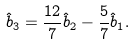Convert formula to latex. <formula><loc_0><loc_0><loc_500><loc_500>\hat { b } _ { 3 } = \frac { 1 2 } { 7 } \hat { b } _ { 2 } - \frac { 5 } { 7 } \hat { b } _ { 1 } .</formula> 